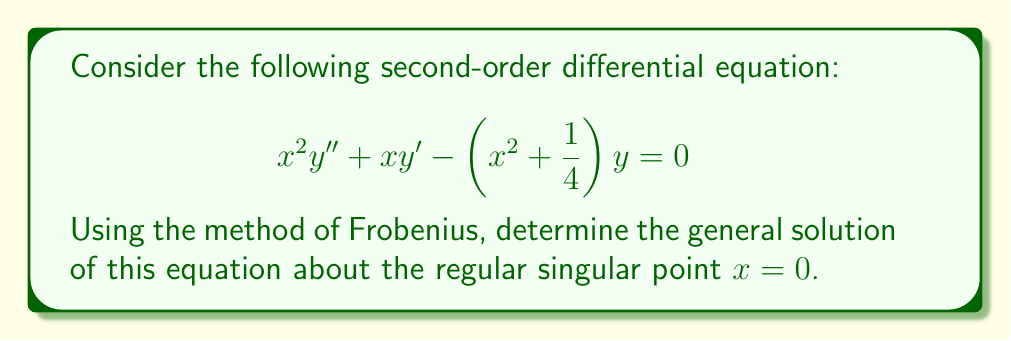Can you solve this math problem? Let's approach this step-by-step using the method of Frobenius:

1) First, we assume a series solution of the form:

   $$ y(x) = x^r \sum_{n=0}^{\infty} a_n x^n = \sum_{n=0}^{\infty} a_n x^{n+r} $$

   where $r$ is to be determined and $a_0 \neq 0$.

2) We need to find $y'$ and $y''$:

   $$ y'(x) = \sum_{n=0}^{\infty} (n+r)a_n x^{n+r-1} $$
   $$ y''(x) = \sum_{n=0}^{\infty} (n+r)(n+r-1)a_n x^{n+r-2} $$

3) Substituting these into the original equation:

   $$ \sum_{n=0}^{\infty} (n+r)(n+r-1)a_n x^n + \sum_{n=0}^{\infty} (n+r)a_n x^n - \sum_{n=0}^{\infty} a_n x^{n+2} - \frac{1}{4}\sum_{n=0}^{\infty} a_n x^n = 0 $$

4) Collecting terms with the same power of $x$:

   $$ \sum_{n=0}^{\infty} [(n+r)(n+r-1)a_n + (n+r)a_n - \frac{1}{4}a_n]x^n - \sum_{n=2}^{\infty} a_{n-2}x^n = 0 $$

5) For this to be true for all $x$, the coefficient of each power of $x$ must be zero. The lowest power of $x$ gives us the indicial equation:

   $$ r(r-1) + r - \frac{1}{4} = 0 $$
   $$ r^2 - \frac{1}{4} = 0 $$
   $$ r = \pm \frac{1}{2} $$

6) For $n \geq 2$, we get the recurrence relation:

   $$ [(n+r)(n+r-1) + (n+r) - \frac{1}{4}]a_n = a_{n-2} $$

   $$ a_n = \frac{a_{n-2}}{(n+r)(n+r-1) + (n+r) - \frac{1}{4}} = \frac{a_{n-2}}{(n+r)^2 - \frac{1}{4}} $$

7) We have two linearly independent solutions corresponding to $r_1 = \frac{1}{2}$ and $r_2 = -\frac{1}{2}$. Let's call them $y_1(x)$ and $y_2(x)$ respectively.

8) For $y_1(x)$ with $r_1 = \frac{1}{2}$:
   $$ y_1(x) = x^{\frac{1}{2}} \sum_{n=0}^{\infty} a_n x^n $$
   where $a_0$ is arbitrary (let's set it to 1), $a_1 = 0$, and for $n \geq 2$:
   $$ a_n = \frac{a_{n-2}}{(n+\frac{1}{2})^2 - \frac{1}{4}} = \frac{a_{n-2}}{n(n+1)} $$

9) For $y_2(x)$ with $r_2 = -\frac{1}{2}$:
   $$ y_2(x) = x^{-\frac{1}{2}} \sum_{n=0}^{\infty} b_n x^n $$
   where $b_0$ is arbitrary (let's set it to 1), $b_1 = 0$, and for $n \geq 2$:
   $$ b_n = \frac{b_{n-2}}{(n-\frac{1}{2})^2 - \frac{1}{4}} = \frac{b_{n-2}}{n(n-1)} $$

10) The general solution is a linear combination of these two solutions.
Answer: The general solution of the given differential equation is:

$$ y(x) = C_1 x^{\frac{1}{2}} \sum_{n=0}^{\infty} \frac{x^{2n}}{(2n)!!} + C_2 x^{-\frac{1}{2}} \sum_{n=0}^{\infty} \frac{x^{2n}}{(2n-1)!!} $$

where $C_1$ and $C_2$ are arbitrary constants, and $n!!$ denotes the double factorial. 